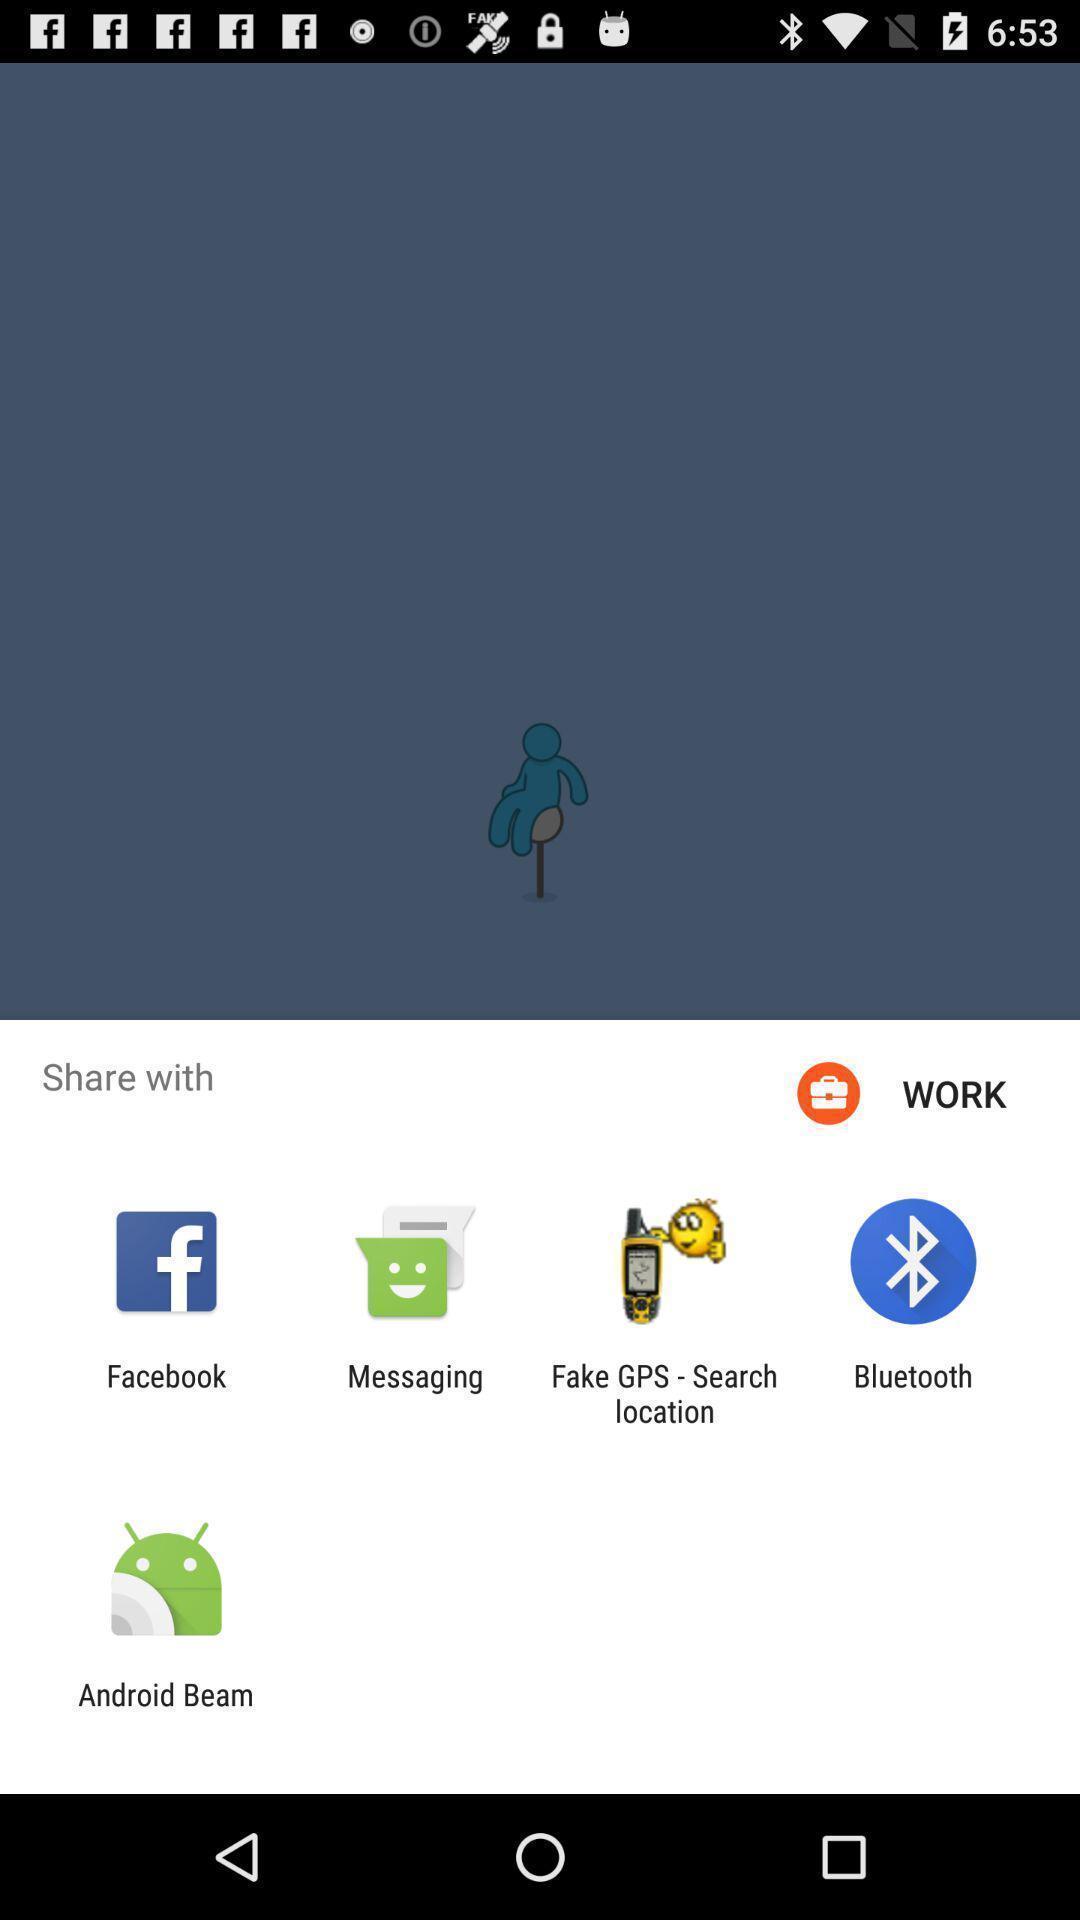Describe this image in words. Pop up showing various apps to share. 